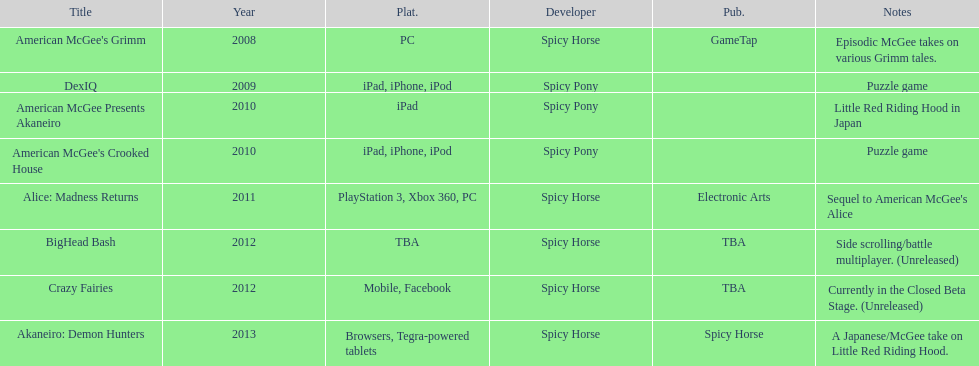What platform was used for the last title on this chart? Browsers, Tegra-powered tablets. 